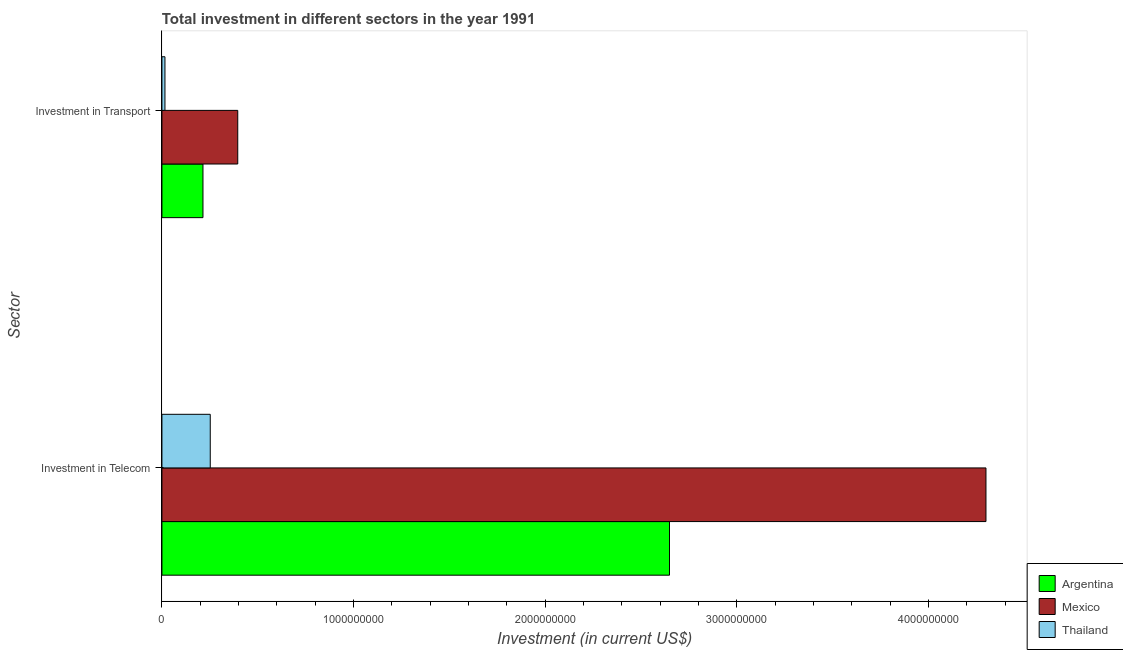How many different coloured bars are there?
Give a very brief answer. 3. How many bars are there on the 2nd tick from the top?
Your answer should be compact. 3. What is the label of the 2nd group of bars from the top?
Make the answer very short. Investment in Telecom. What is the investment in transport in Argentina?
Give a very brief answer. 2.14e+08. Across all countries, what is the maximum investment in telecom?
Provide a succinct answer. 4.30e+09. Across all countries, what is the minimum investment in telecom?
Make the answer very short. 2.52e+08. In which country was the investment in telecom maximum?
Your answer should be compact. Mexico. In which country was the investment in transport minimum?
Make the answer very short. Thailand. What is the total investment in transport in the graph?
Ensure brevity in your answer.  6.25e+08. What is the difference between the investment in telecom in Thailand and that in Argentina?
Provide a short and direct response. -2.40e+09. What is the difference between the investment in telecom in Argentina and the investment in transport in Thailand?
Provide a short and direct response. 2.63e+09. What is the average investment in telecom per country?
Offer a terse response. 2.40e+09. What is the difference between the investment in telecom and investment in transport in Thailand?
Your answer should be compact. 2.36e+08. In how many countries, is the investment in telecom greater than 3000000000 US$?
Your response must be concise. 1. What is the ratio of the investment in transport in Mexico to that in Thailand?
Give a very brief answer. 25.19. What does the 2nd bar from the top in Investment in Telecom represents?
Your answer should be very brief. Mexico. Are all the bars in the graph horizontal?
Offer a terse response. Yes. How many countries are there in the graph?
Give a very brief answer. 3. What is the difference between two consecutive major ticks on the X-axis?
Keep it short and to the point. 1.00e+09. Does the graph contain grids?
Provide a short and direct response. No. Where does the legend appear in the graph?
Provide a short and direct response. Bottom right. How many legend labels are there?
Give a very brief answer. 3. What is the title of the graph?
Keep it short and to the point. Total investment in different sectors in the year 1991. Does "Korea (Democratic)" appear as one of the legend labels in the graph?
Ensure brevity in your answer.  No. What is the label or title of the X-axis?
Provide a short and direct response. Investment (in current US$). What is the label or title of the Y-axis?
Offer a very short reply. Sector. What is the Investment (in current US$) of Argentina in Investment in Telecom?
Provide a short and direct response. 2.65e+09. What is the Investment (in current US$) in Mexico in Investment in Telecom?
Make the answer very short. 4.30e+09. What is the Investment (in current US$) in Thailand in Investment in Telecom?
Provide a succinct answer. 2.52e+08. What is the Investment (in current US$) of Argentina in Investment in Transport?
Your response must be concise. 2.14e+08. What is the Investment (in current US$) in Mexico in Investment in Transport?
Your answer should be compact. 3.96e+08. What is the Investment (in current US$) in Thailand in Investment in Transport?
Your answer should be very brief. 1.57e+07. Across all Sector, what is the maximum Investment (in current US$) of Argentina?
Offer a very short reply. 2.65e+09. Across all Sector, what is the maximum Investment (in current US$) in Mexico?
Offer a terse response. 4.30e+09. Across all Sector, what is the maximum Investment (in current US$) of Thailand?
Offer a very short reply. 2.52e+08. Across all Sector, what is the minimum Investment (in current US$) of Argentina?
Provide a succinct answer. 2.14e+08. Across all Sector, what is the minimum Investment (in current US$) of Mexico?
Offer a terse response. 3.96e+08. Across all Sector, what is the minimum Investment (in current US$) of Thailand?
Provide a succinct answer. 1.57e+07. What is the total Investment (in current US$) in Argentina in the graph?
Keep it short and to the point. 2.86e+09. What is the total Investment (in current US$) in Mexico in the graph?
Your answer should be very brief. 4.69e+09. What is the total Investment (in current US$) of Thailand in the graph?
Make the answer very short. 2.68e+08. What is the difference between the Investment (in current US$) of Argentina in Investment in Telecom and that in Investment in Transport?
Your answer should be compact. 2.43e+09. What is the difference between the Investment (in current US$) in Mexico in Investment in Telecom and that in Investment in Transport?
Make the answer very short. 3.90e+09. What is the difference between the Investment (in current US$) in Thailand in Investment in Telecom and that in Investment in Transport?
Offer a terse response. 2.36e+08. What is the difference between the Investment (in current US$) in Argentina in Investment in Telecom and the Investment (in current US$) in Mexico in Investment in Transport?
Offer a terse response. 2.25e+09. What is the difference between the Investment (in current US$) in Argentina in Investment in Telecom and the Investment (in current US$) in Thailand in Investment in Transport?
Provide a succinct answer. 2.63e+09. What is the difference between the Investment (in current US$) of Mexico in Investment in Telecom and the Investment (in current US$) of Thailand in Investment in Transport?
Your response must be concise. 4.28e+09. What is the average Investment (in current US$) in Argentina per Sector?
Your answer should be compact. 1.43e+09. What is the average Investment (in current US$) of Mexico per Sector?
Ensure brevity in your answer.  2.35e+09. What is the average Investment (in current US$) of Thailand per Sector?
Your response must be concise. 1.34e+08. What is the difference between the Investment (in current US$) of Argentina and Investment (in current US$) of Mexico in Investment in Telecom?
Offer a very short reply. -1.65e+09. What is the difference between the Investment (in current US$) in Argentina and Investment (in current US$) in Thailand in Investment in Telecom?
Your answer should be very brief. 2.40e+09. What is the difference between the Investment (in current US$) of Mexico and Investment (in current US$) of Thailand in Investment in Telecom?
Your answer should be very brief. 4.05e+09. What is the difference between the Investment (in current US$) of Argentina and Investment (in current US$) of Mexico in Investment in Transport?
Provide a short and direct response. -1.82e+08. What is the difference between the Investment (in current US$) in Argentina and Investment (in current US$) in Thailand in Investment in Transport?
Offer a terse response. 1.98e+08. What is the difference between the Investment (in current US$) of Mexico and Investment (in current US$) of Thailand in Investment in Transport?
Offer a very short reply. 3.80e+08. What is the ratio of the Investment (in current US$) in Argentina in Investment in Telecom to that in Investment in Transport?
Make the answer very short. 12.37. What is the ratio of the Investment (in current US$) of Mexico in Investment in Telecom to that in Investment in Transport?
Keep it short and to the point. 10.87. What is the ratio of the Investment (in current US$) of Thailand in Investment in Telecom to that in Investment in Transport?
Provide a succinct answer. 16.05. What is the difference between the highest and the second highest Investment (in current US$) in Argentina?
Your answer should be very brief. 2.43e+09. What is the difference between the highest and the second highest Investment (in current US$) in Mexico?
Ensure brevity in your answer.  3.90e+09. What is the difference between the highest and the second highest Investment (in current US$) of Thailand?
Provide a short and direct response. 2.36e+08. What is the difference between the highest and the lowest Investment (in current US$) of Argentina?
Provide a succinct answer. 2.43e+09. What is the difference between the highest and the lowest Investment (in current US$) of Mexico?
Provide a succinct answer. 3.90e+09. What is the difference between the highest and the lowest Investment (in current US$) of Thailand?
Offer a very short reply. 2.36e+08. 